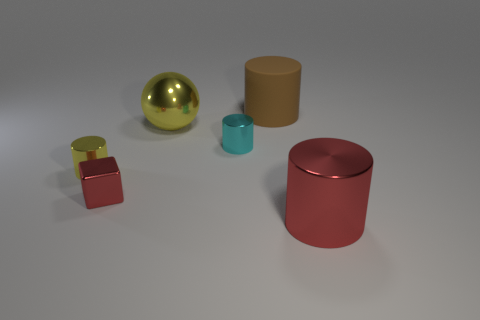There is a object that is both behind the small cyan cylinder and to the left of the brown rubber cylinder; what size is it?
Your answer should be compact. Large. What number of red objects are large metallic things or large cubes?
Make the answer very short. 1. There is a red thing that is the same size as the yellow metal cylinder; what shape is it?
Provide a short and direct response. Cube. How many other objects are the same color as the cube?
Offer a very short reply. 1. There is a red shiny object that is on the left side of the big brown rubber cylinder behind the tiny cyan thing; what is its size?
Offer a terse response. Small. Is the yellow thing that is to the right of the red metal block made of the same material as the brown thing?
Keep it short and to the point. No. The tiny object right of the large yellow metal ball has what shape?
Your answer should be very brief. Cylinder. How many objects have the same size as the metal cube?
Your answer should be compact. 2. What size is the yellow ball?
Provide a succinct answer. Large. There is a brown object; how many big cylinders are to the right of it?
Keep it short and to the point. 1. 